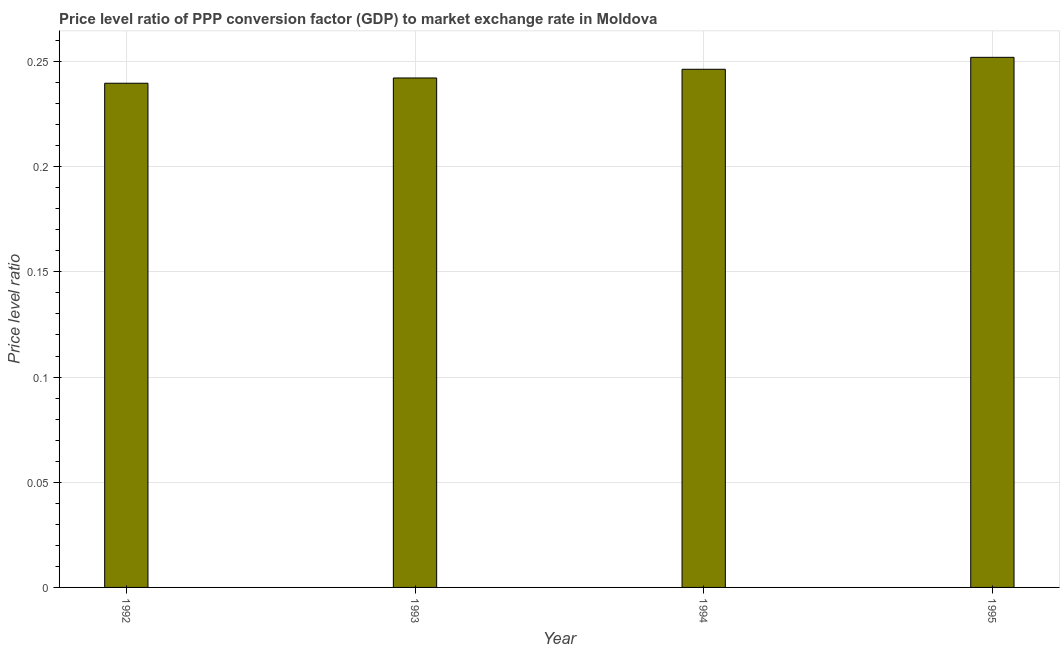Does the graph contain any zero values?
Make the answer very short. No. What is the title of the graph?
Your response must be concise. Price level ratio of PPP conversion factor (GDP) to market exchange rate in Moldova. What is the label or title of the X-axis?
Provide a succinct answer. Year. What is the label or title of the Y-axis?
Give a very brief answer. Price level ratio. What is the price level ratio in 1993?
Provide a short and direct response. 0.24. Across all years, what is the maximum price level ratio?
Your answer should be compact. 0.25. Across all years, what is the minimum price level ratio?
Offer a very short reply. 0.24. What is the sum of the price level ratio?
Give a very brief answer. 0.98. What is the difference between the price level ratio in 1994 and 1995?
Offer a very short reply. -0.01. What is the average price level ratio per year?
Your answer should be compact. 0.24. What is the median price level ratio?
Your answer should be compact. 0.24. Do a majority of the years between 1992 and 1995 (inclusive) have price level ratio greater than 0.06 ?
Provide a short and direct response. Yes. What is the difference between the highest and the second highest price level ratio?
Ensure brevity in your answer.  0.01. Is the sum of the price level ratio in 1994 and 1995 greater than the maximum price level ratio across all years?
Keep it short and to the point. Yes. What is the difference between the highest and the lowest price level ratio?
Offer a terse response. 0.01. How many bars are there?
Ensure brevity in your answer.  4. Are the values on the major ticks of Y-axis written in scientific E-notation?
Offer a very short reply. No. What is the Price level ratio of 1992?
Your answer should be compact. 0.24. What is the Price level ratio of 1993?
Provide a succinct answer. 0.24. What is the Price level ratio in 1994?
Your answer should be compact. 0.25. What is the Price level ratio of 1995?
Offer a very short reply. 0.25. What is the difference between the Price level ratio in 1992 and 1993?
Your answer should be compact. -0. What is the difference between the Price level ratio in 1992 and 1994?
Your response must be concise. -0.01. What is the difference between the Price level ratio in 1992 and 1995?
Offer a terse response. -0.01. What is the difference between the Price level ratio in 1993 and 1994?
Offer a very short reply. -0. What is the difference between the Price level ratio in 1993 and 1995?
Your answer should be very brief. -0.01. What is the difference between the Price level ratio in 1994 and 1995?
Your answer should be compact. -0.01. What is the ratio of the Price level ratio in 1992 to that in 1993?
Your answer should be compact. 0.99. What is the ratio of the Price level ratio in 1992 to that in 1995?
Your answer should be compact. 0.95. 